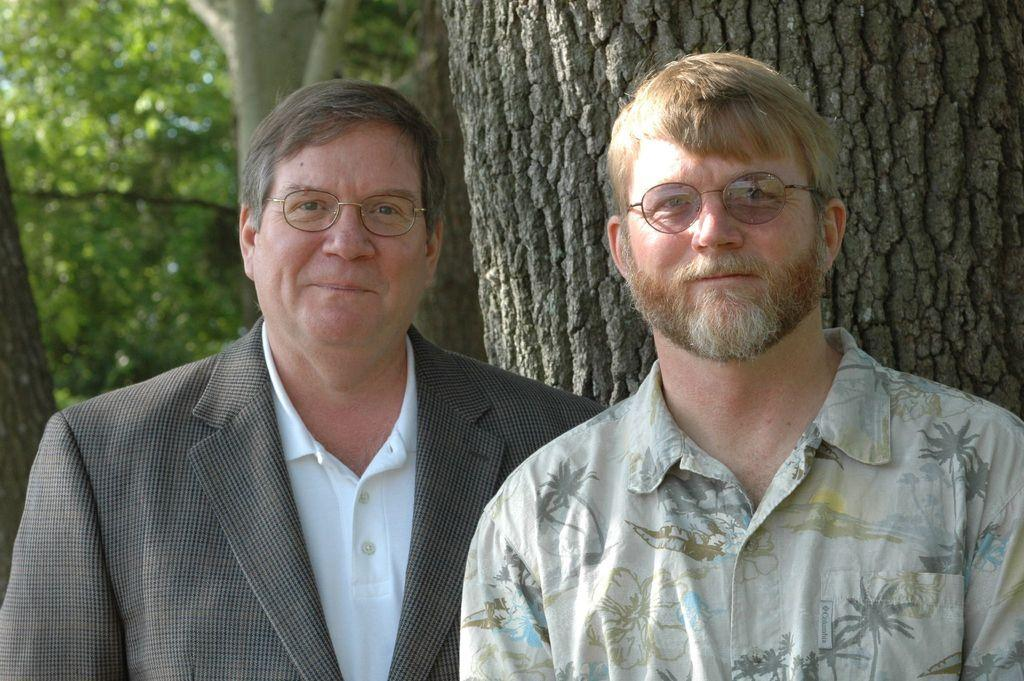How many people are in the image? There are two men in the image. What are the men doing in the image? The men are standing in the image. What can be seen on the faces of the men? The men are wearing spectacles in the image. What type of natural environment is visible in the image? There are trees visible in the image, and the bark of the trees is also visible. Where is the girl sitting in the image? There is no girl present in the image. What type of heart-shaped object can be seen in the image? There is no heart-shaped object present in the image. 